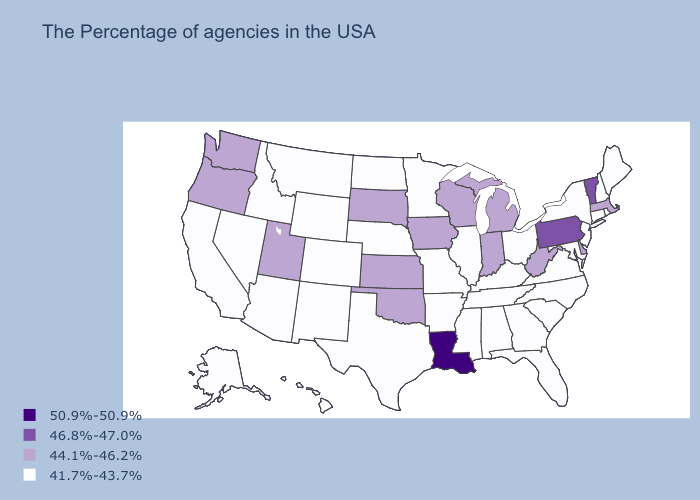What is the value of Tennessee?
Keep it brief. 41.7%-43.7%. Among the states that border New Hampshire , does Massachusetts have the lowest value?
Write a very short answer. No. Does New Hampshire have a lower value than Missouri?
Write a very short answer. No. What is the value of Illinois?
Quick response, please. 41.7%-43.7%. Does South Dakota have the same value as Tennessee?
Give a very brief answer. No. Does Kansas have a higher value than Arizona?
Quick response, please. Yes. Name the states that have a value in the range 44.1%-46.2%?
Write a very short answer. Massachusetts, Delaware, West Virginia, Michigan, Indiana, Wisconsin, Iowa, Kansas, Oklahoma, South Dakota, Utah, Washington, Oregon. Name the states that have a value in the range 41.7%-43.7%?
Write a very short answer. Maine, Rhode Island, New Hampshire, Connecticut, New York, New Jersey, Maryland, Virginia, North Carolina, South Carolina, Ohio, Florida, Georgia, Kentucky, Alabama, Tennessee, Illinois, Mississippi, Missouri, Arkansas, Minnesota, Nebraska, Texas, North Dakota, Wyoming, Colorado, New Mexico, Montana, Arizona, Idaho, Nevada, California, Alaska, Hawaii. Does Oregon have the lowest value in the West?
Write a very short answer. No. What is the value of New Mexico?
Quick response, please. 41.7%-43.7%. Which states have the lowest value in the West?
Short answer required. Wyoming, Colorado, New Mexico, Montana, Arizona, Idaho, Nevada, California, Alaska, Hawaii. What is the lowest value in the MidWest?
Answer briefly. 41.7%-43.7%. What is the lowest value in states that border Texas?
Answer briefly. 41.7%-43.7%. What is the lowest value in states that border Missouri?
Be succinct. 41.7%-43.7%. Name the states that have a value in the range 44.1%-46.2%?
Quick response, please. Massachusetts, Delaware, West Virginia, Michigan, Indiana, Wisconsin, Iowa, Kansas, Oklahoma, South Dakota, Utah, Washington, Oregon. 